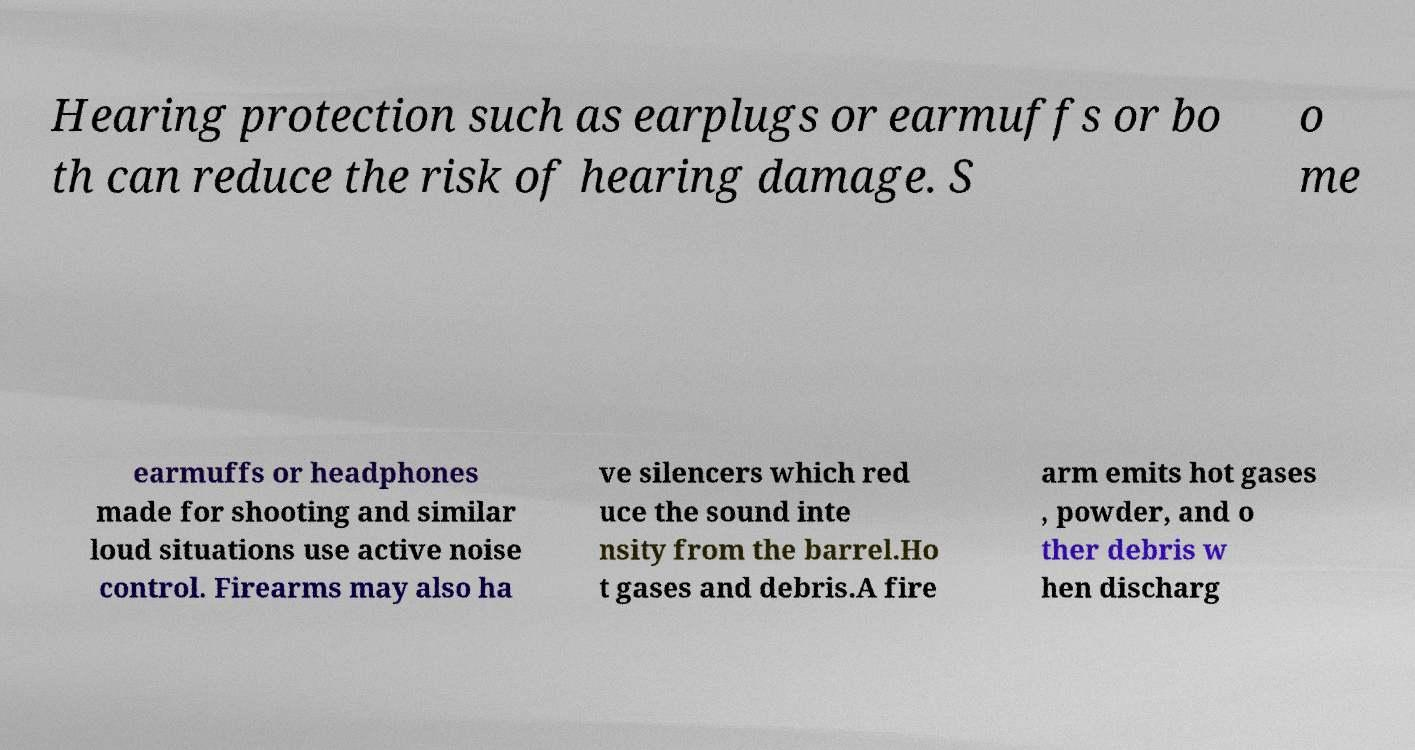For documentation purposes, I need the text within this image transcribed. Could you provide that? Hearing protection such as earplugs or earmuffs or bo th can reduce the risk of hearing damage. S o me earmuffs or headphones made for shooting and similar loud situations use active noise control. Firearms may also ha ve silencers which red uce the sound inte nsity from the barrel.Ho t gases and debris.A fire arm emits hot gases , powder, and o ther debris w hen discharg 